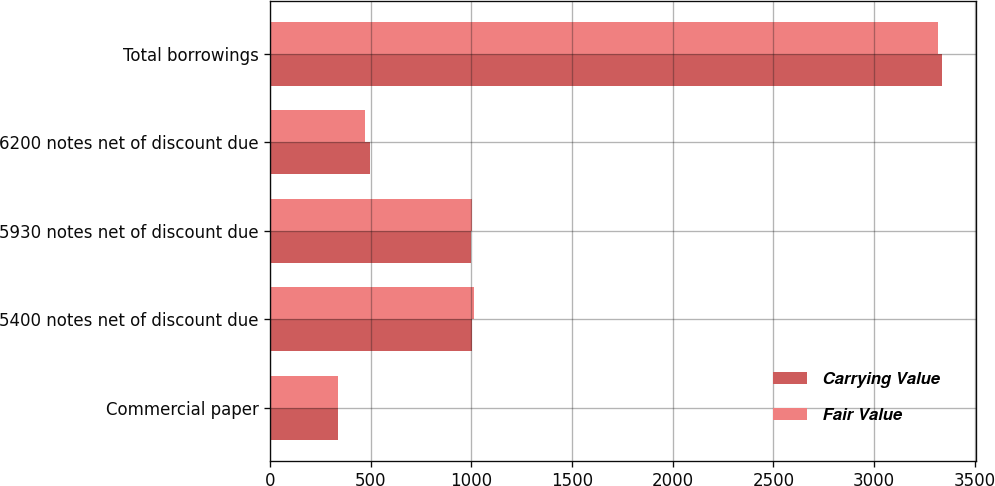Convert chart. <chart><loc_0><loc_0><loc_500><loc_500><stacked_bar_chart><ecel><fcel>Commercial paper<fcel>5400 notes net of discount due<fcel>5930 notes net of discount due<fcel>6200 notes net of discount due<fcel>Total borrowings<nl><fcel>Carrying Value<fcel>338.2<fcel>1002.8<fcel>999.7<fcel>497.3<fcel>3338<nl><fcel>Fair Value<fcel>338.2<fcel>1012<fcel>1001.2<fcel>473.1<fcel>3319.7<nl></chart> 